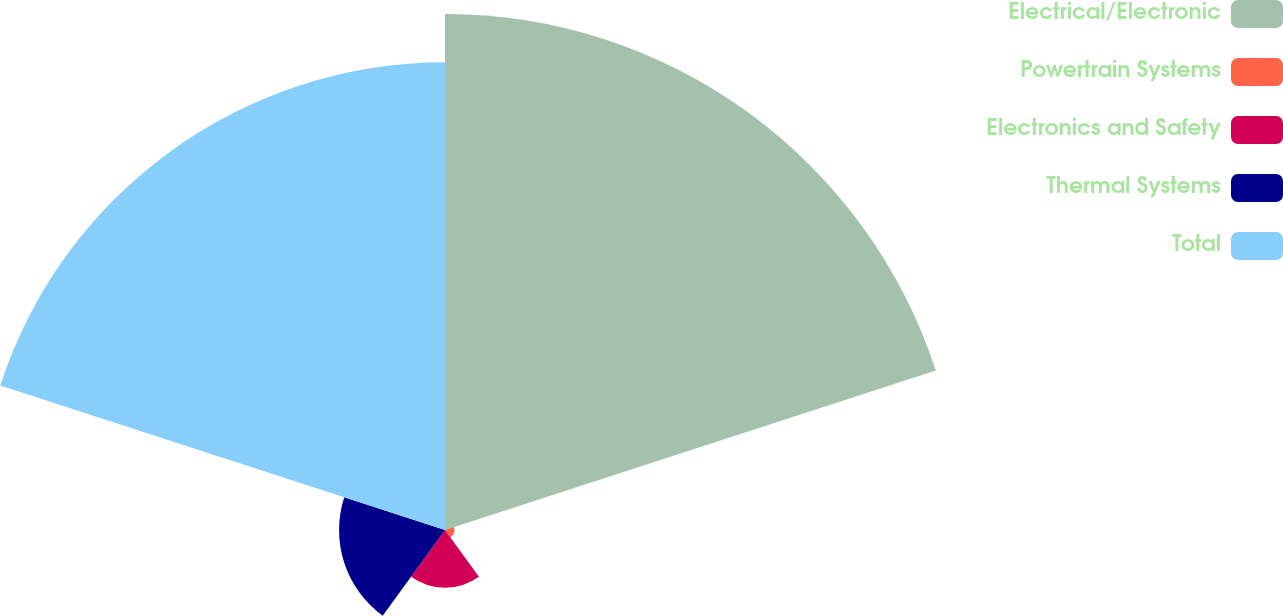Convert chart to OTSL. <chart><loc_0><loc_0><loc_500><loc_500><pie_chart><fcel>Electrical/Electronic<fcel>Powertrain Systems<fcel>Electronics and Safety<fcel>Thermal Systems<fcel>Total<nl><fcel>44.61%<fcel>0.81%<fcel>4.99%<fcel>9.16%<fcel>40.43%<nl></chart> 